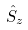<formula> <loc_0><loc_0><loc_500><loc_500>\hat { S } _ { z }</formula> 